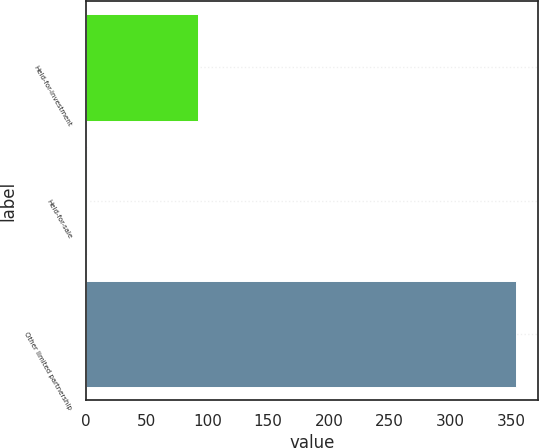<chart> <loc_0><loc_0><loc_500><loc_500><bar_chart><fcel>Held-for-investment<fcel>Held-for-sale<fcel>Other limited partnership<nl><fcel>92<fcel>1<fcel>354<nl></chart> 